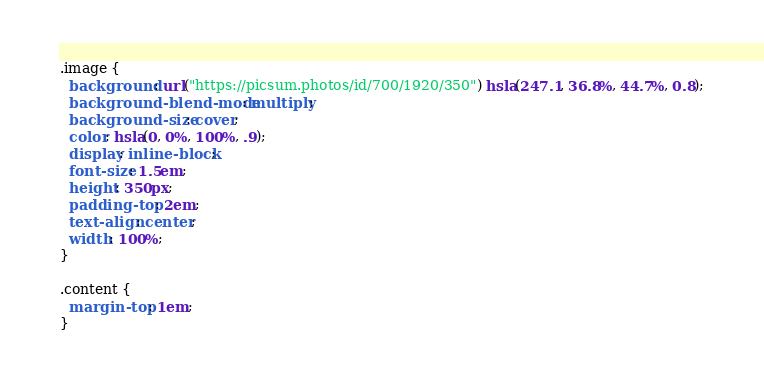<code> <loc_0><loc_0><loc_500><loc_500><_CSS_>.image {
  background: url("https://picsum.photos/id/700/1920/350") hsla(247.1, 36.8%, 44.7%, 0.8);
  background-blend-mode: multiply;
  background-size: cover;
  color: hsla(0, 0%, 100%, .9);
  display: inline-block;
  font-size: 1.5em;
  height: 350px;
  padding-top: 2em;
  text-align: center;
  width: 100%;
}

.content {
  margin-top: 1em;
}</code> 